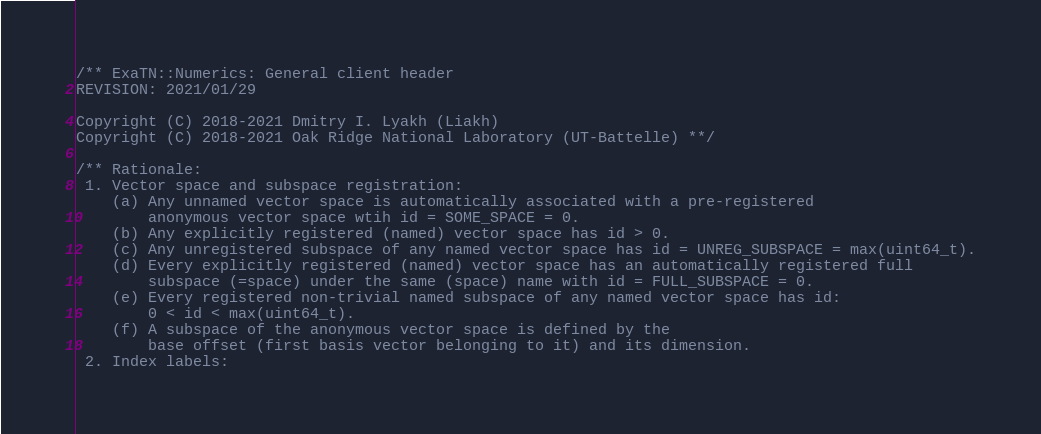Convert code to text. <code><loc_0><loc_0><loc_500><loc_500><_C++_>/** ExaTN::Numerics: General client header
REVISION: 2021/01/29

Copyright (C) 2018-2021 Dmitry I. Lyakh (Liakh)
Copyright (C) 2018-2021 Oak Ridge National Laboratory (UT-Battelle) **/

/** Rationale:
 1. Vector space and subspace registration:
    (a) Any unnamed vector space is automatically associated with a pre-registered
        anonymous vector space wtih id = SOME_SPACE = 0.
    (b) Any explicitly registered (named) vector space has id > 0.
    (c) Any unregistered subspace of any named vector space has id = UNREG_SUBSPACE = max(uint64_t).
    (d) Every explicitly registered (named) vector space has an automatically registered full
        subspace (=space) under the same (space) name with id = FULL_SUBSPACE = 0.
    (e) Every registered non-trivial named subspace of any named vector space has id:
        0 < id < max(uint64_t).
    (f) A subspace of the anonymous vector space is defined by the
        base offset (first basis vector belonging to it) and its dimension.
 2. Index labels:</code> 